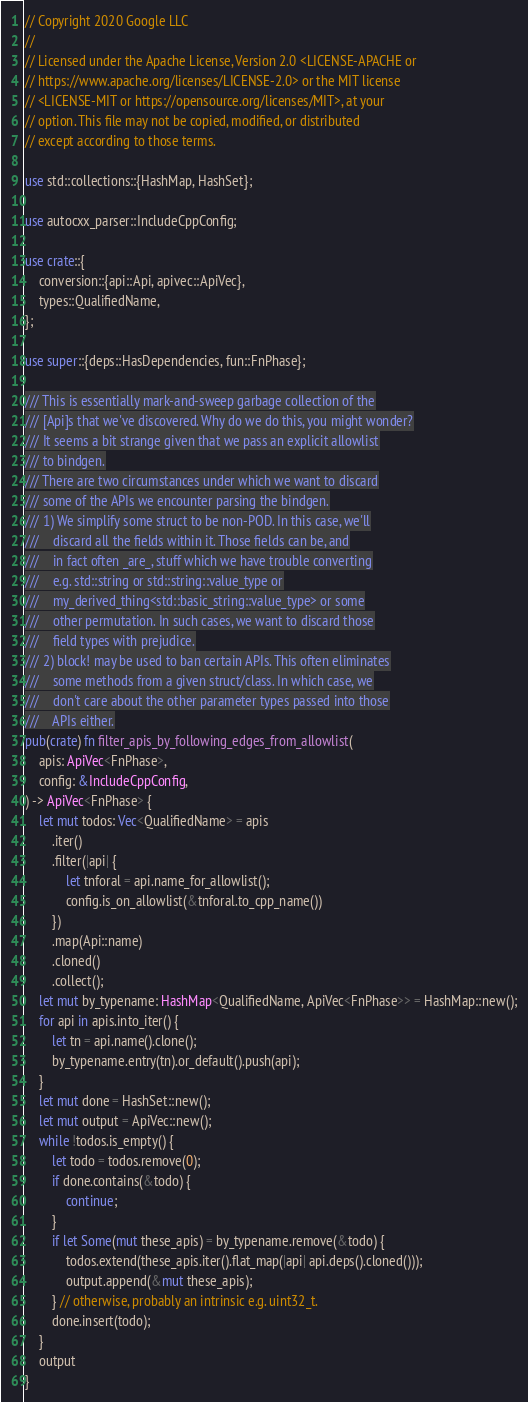Convert code to text. <code><loc_0><loc_0><loc_500><loc_500><_Rust_>// Copyright 2020 Google LLC
//
// Licensed under the Apache License, Version 2.0 <LICENSE-APACHE or
// https://www.apache.org/licenses/LICENSE-2.0> or the MIT license
// <LICENSE-MIT or https://opensource.org/licenses/MIT>, at your
// option. This file may not be copied, modified, or distributed
// except according to those terms.

use std::collections::{HashMap, HashSet};

use autocxx_parser::IncludeCppConfig;

use crate::{
    conversion::{api::Api, apivec::ApiVec},
    types::QualifiedName,
};

use super::{deps::HasDependencies, fun::FnPhase};

/// This is essentially mark-and-sweep garbage collection of the
/// [Api]s that we've discovered. Why do we do this, you might wonder?
/// It seems a bit strange given that we pass an explicit allowlist
/// to bindgen.
/// There are two circumstances under which we want to discard
/// some of the APIs we encounter parsing the bindgen.
/// 1) We simplify some struct to be non-POD. In this case, we'll
///    discard all the fields within it. Those fields can be, and
///    in fact often _are_, stuff which we have trouble converting
///    e.g. std::string or std::string::value_type or
///    my_derived_thing<std::basic_string::value_type> or some
///    other permutation. In such cases, we want to discard those
///    field types with prejudice.
/// 2) block! may be used to ban certain APIs. This often eliminates
///    some methods from a given struct/class. In which case, we
///    don't care about the other parameter types passed into those
///    APIs either.
pub(crate) fn filter_apis_by_following_edges_from_allowlist(
    apis: ApiVec<FnPhase>,
    config: &IncludeCppConfig,
) -> ApiVec<FnPhase> {
    let mut todos: Vec<QualifiedName> = apis
        .iter()
        .filter(|api| {
            let tnforal = api.name_for_allowlist();
            config.is_on_allowlist(&tnforal.to_cpp_name())
        })
        .map(Api::name)
        .cloned()
        .collect();
    let mut by_typename: HashMap<QualifiedName, ApiVec<FnPhase>> = HashMap::new();
    for api in apis.into_iter() {
        let tn = api.name().clone();
        by_typename.entry(tn).or_default().push(api);
    }
    let mut done = HashSet::new();
    let mut output = ApiVec::new();
    while !todos.is_empty() {
        let todo = todos.remove(0);
        if done.contains(&todo) {
            continue;
        }
        if let Some(mut these_apis) = by_typename.remove(&todo) {
            todos.extend(these_apis.iter().flat_map(|api| api.deps().cloned()));
            output.append(&mut these_apis);
        } // otherwise, probably an intrinsic e.g. uint32_t.
        done.insert(todo);
    }
    output
}
</code> 